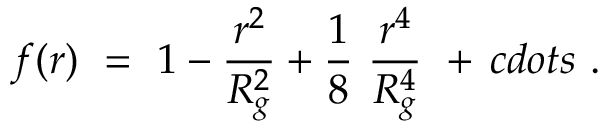<formula> <loc_0><loc_0><loc_500><loc_500>f ( r ) \ = \ 1 - \frac { r ^ { 2 } } { R _ { g } ^ { 2 } } + \frac { 1 } { 8 } \ \frac { r ^ { 4 } } { R _ { g } ^ { 4 } } \ + \, c d o t s \ .</formula> 